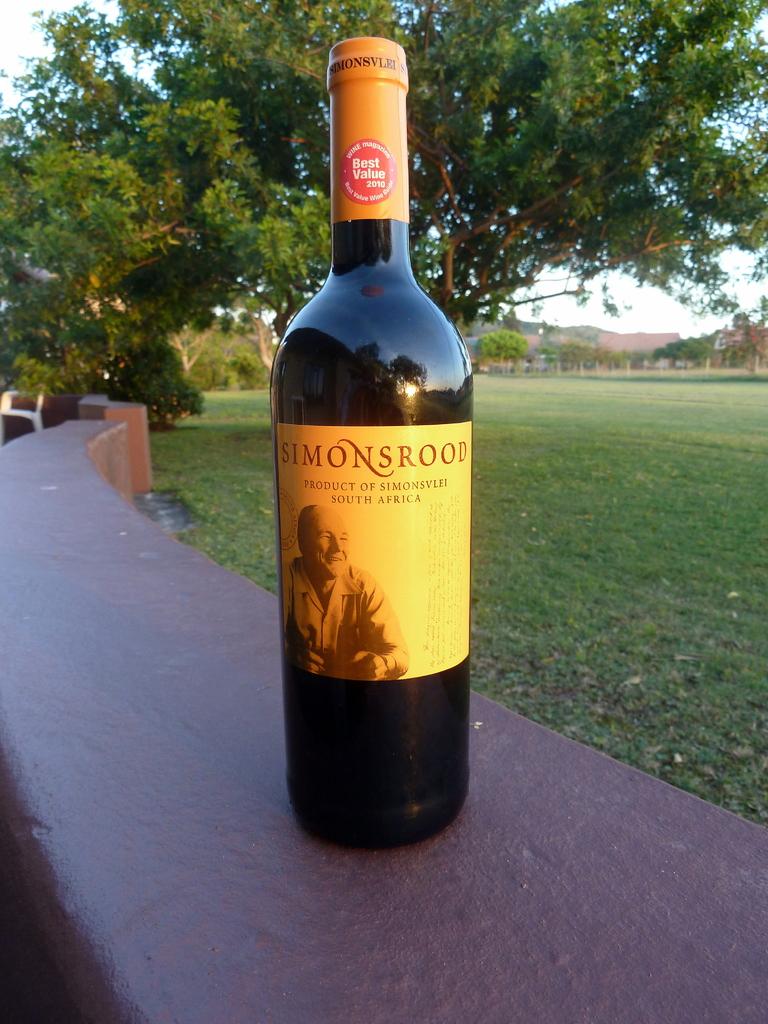What is the name of the wine?
Your answer should be compact. Simonsrood. Where is this a product of?
Offer a very short reply. South africa. 